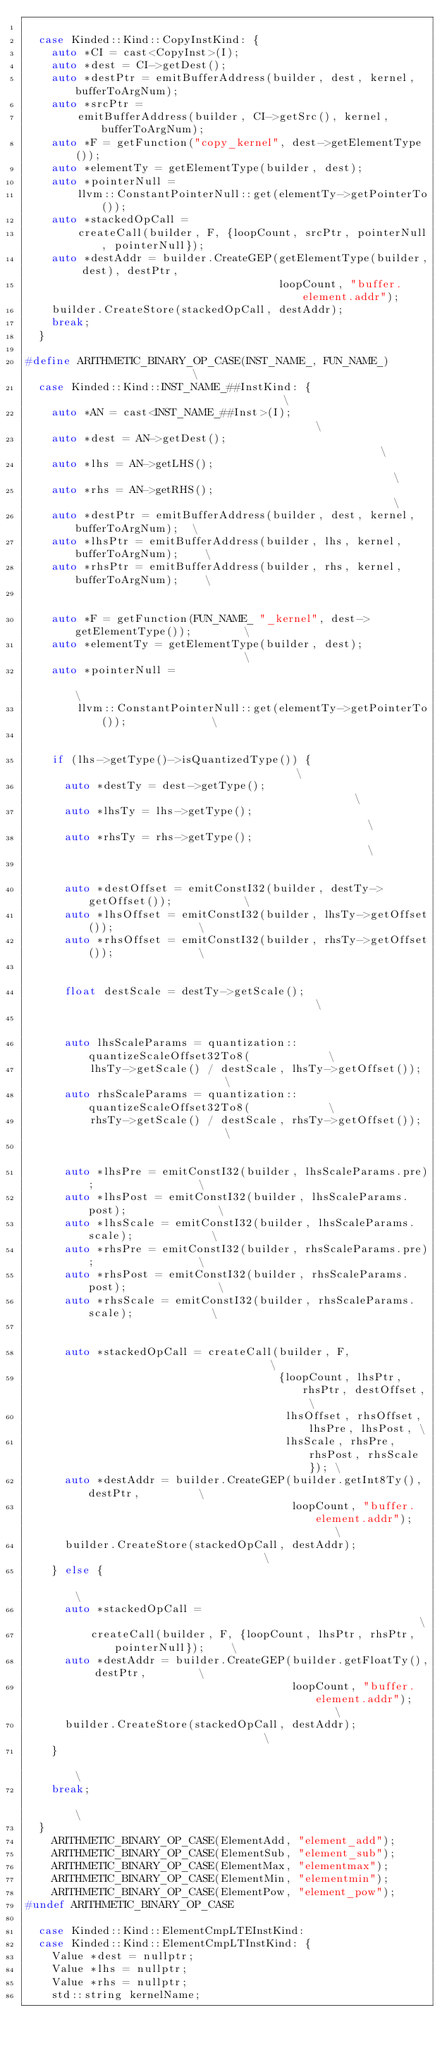Convert code to text. <code><loc_0><loc_0><loc_500><loc_500><_C++_>
  case Kinded::Kind::CopyInstKind: {
    auto *CI = cast<CopyInst>(I);
    auto *dest = CI->getDest();
    auto *destPtr = emitBufferAddress(builder, dest, kernel, bufferToArgNum);
    auto *srcPtr =
        emitBufferAddress(builder, CI->getSrc(), kernel, bufferToArgNum);
    auto *F = getFunction("copy_kernel", dest->getElementType());
    auto *elementTy = getElementType(builder, dest);
    auto *pointerNull =
        llvm::ConstantPointerNull::get(elementTy->getPointerTo());
    auto *stackedOpCall =
        createCall(builder, F, {loopCount, srcPtr, pointerNull, pointerNull});
    auto *destAddr = builder.CreateGEP(getElementType(builder, dest), destPtr,
                                       loopCount, "buffer.element.addr");
    builder.CreateStore(stackedOpCall, destAddr);
    break;
  }

#define ARITHMETIC_BINARY_OP_CASE(INST_NAME_, FUN_NAME_)                       \
  case Kinded::Kind::INST_NAME_##InstKind: {                                   \
    auto *AN = cast<INST_NAME_##Inst>(I);                                      \
    auto *dest = AN->getDest();                                                \
    auto *lhs = AN->getLHS();                                                  \
    auto *rhs = AN->getRHS();                                                  \
    auto *destPtr = emitBufferAddress(builder, dest, kernel, bufferToArgNum);  \
    auto *lhsPtr = emitBufferAddress(builder, lhs, kernel, bufferToArgNum);    \
    auto *rhsPtr = emitBufferAddress(builder, rhs, kernel, bufferToArgNum);    \
                                                                               \
    auto *F = getFunction(FUN_NAME_ "_kernel", dest->getElementType());        \
    auto *elementTy = getElementType(builder, dest);                           \
    auto *pointerNull =                                                        \
        llvm::ConstantPointerNull::get(elementTy->getPointerTo());             \
                                                                               \
    if (lhs->getType()->isQuantizedType()) {                                   \
      auto *destTy = dest->getType();                                          \
      auto *lhsTy = lhs->getType();                                            \
      auto *rhsTy = rhs->getType();                                            \
                                                                               \
      auto *destOffset = emitConstI32(builder, destTy->getOffset());           \
      auto *lhsOffset = emitConstI32(builder, lhsTy->getOffset());             \
      auto *rhsOffset = emitConstI32(builder, rhsTy->getOffset());             \
                                                                               \
      float destScale = destTy->getScale();                                    \
                                                                               \
      auto lhsScaleParams = quantization::quantizeScaleOffset32To8(            \
          lhsTy->getScale() / destScale, lhsTy->getOffset());                  \
      auto rhsScaleParams = quantization::quantizeScaleOffset32To8(            \
          rhsTy->getScale() / destScale, rhsTy->getOffset());                  \
                                                                               \
      auto *lhsPre = emitConstI32(builder, lhsScaleParams.pre);                \
      auto *lhsPost = emitConstI32(builder, lhsScaleParams.post);              \
      auto *lhsScale = emitConstI32(builder, lhsScaleParams.scale);            \
      auto *rhsPre = emitConstI32(builder, rhsScaleParams.pre);                \
      auto *rhsPost = emitConstI32(builder, rhsScaleParams.post);              \
      auto *rhsScale = emitConstI32(builder, rhsScaleParams.scale);            \
                                                                               \
      auto *stackedOpCall = createCall(builder, F,                             \
                                       {loopCount, lhsPtr, rhsPtr, destOffset, \
                                        lhsOffset, rhsOffset, lhsPre, lhsPost, \
                                        lhsScale, rhsPre, rhsPost, rhsScale}); \
      auto *destAddr = builder.CreateGEP(builder.getInt8Ty(), destPtr,         \
                                         loopCount, "buffer.element.addr");    \
      builder.CreateStore(stackedOpCall, destAddr);                            \
    } else {                                                                   \
      auto *stackedOpCall =                                                    \
          createCall(builder, F, {loopCount, lhsPtr, rhsPtr, pointerNull});    \
      auto *destAddr = builder.CreateGEP(builder.getFloatTy(), destPtr,        \
                                         loopCount, "buffer.element.addr");    \
      builder.CreateStore(stackedOpCall, destAddr);                            \
    }                                                                          \
    break;                                                                     \
  }
    ARITHMETIC_BINARY_OP_CASE(ElementAdd, "element_add");
    ARITHMETIC_BINARY_OP_CASE(ElementSub, "element_sub");
    ARITHMETIC_BINARY_OP_CASE(ElementMax, "elementmax");
    ARITHMETIC_BINARY_OP_CASE(ElementMin, "elementmin");
    ARITHMETIC_BINARY_OP_CASE(ElementPow, "element_pow");
#undef ARITHMETIC_BINARY_OP_CASE

  case Kinded::Kind::ElementCmpLTEInstKind:
  case Kinded::Kind::ElementCmpLTInstKind: {
    Value *dest = nullptr;
    Value *lhs = nullptr;
    Value *rhs = nullptr;
    std::string kernelName;
</code> 